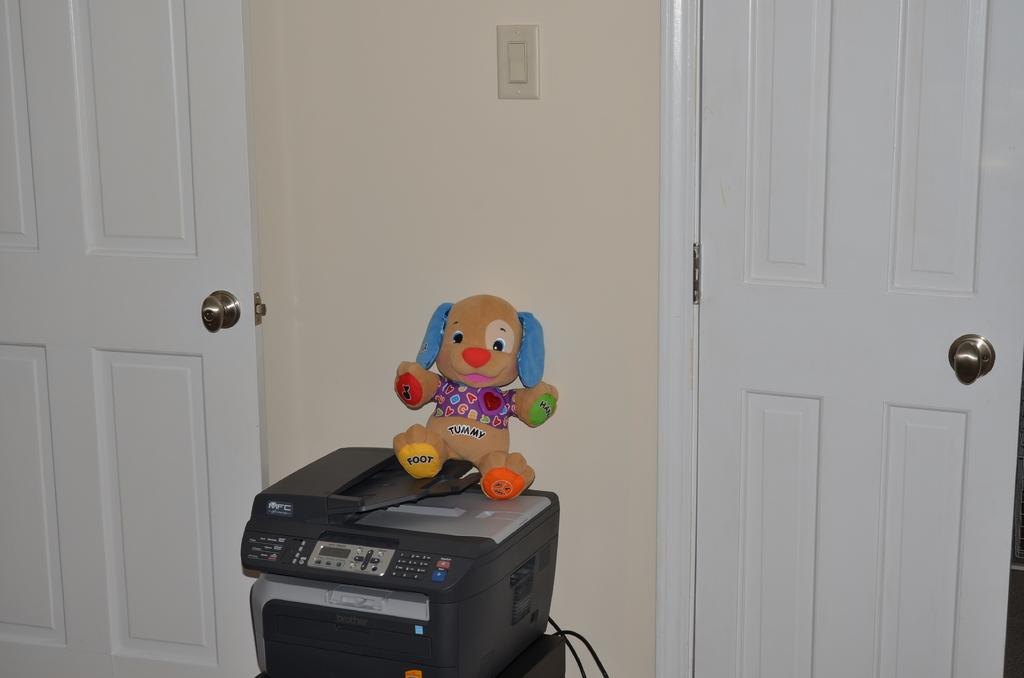What object is placed on the printer in the image? There is a soft toy on the printer. What can be seen in the background of the image? There are doors visible in the background. What feature is present on the wall in the background? There is a switch on the wall in the background. What type of sugar is being stored in the stocking hanging from the trousers in the image? There are no stockings, trousers, or sugar present in the image. 